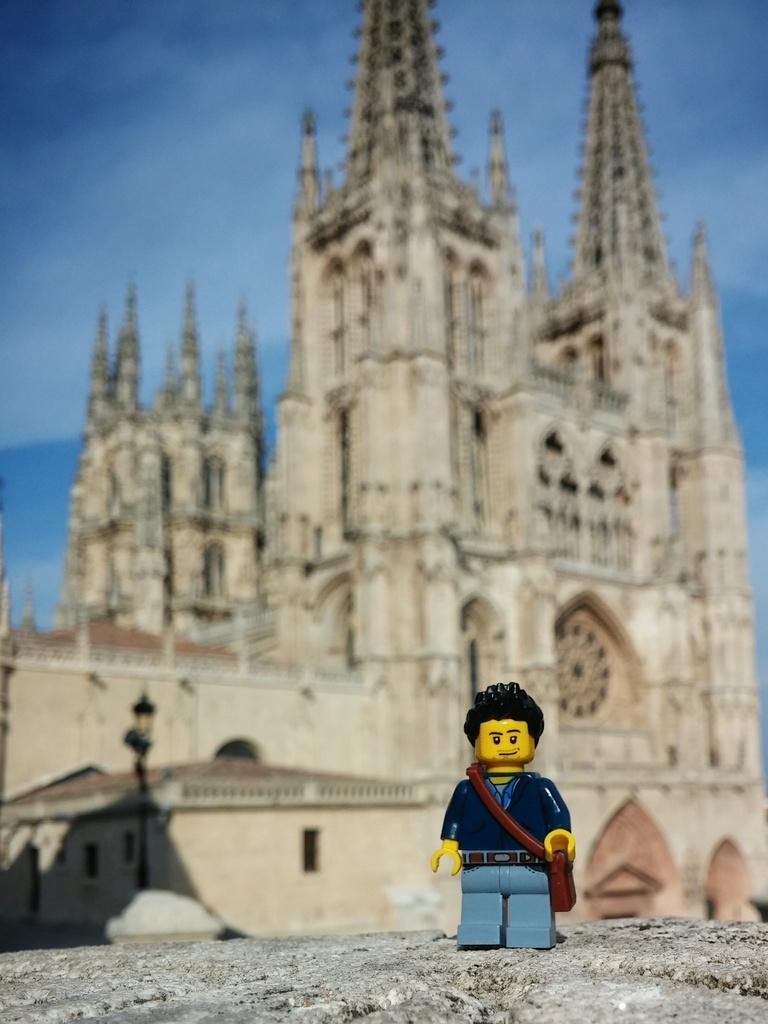Describe this image in one or two sentences. In this image at front there is a depiction of a boy. At the back side there is a church and in front of the church there is a street light. In the background there is the sky. 